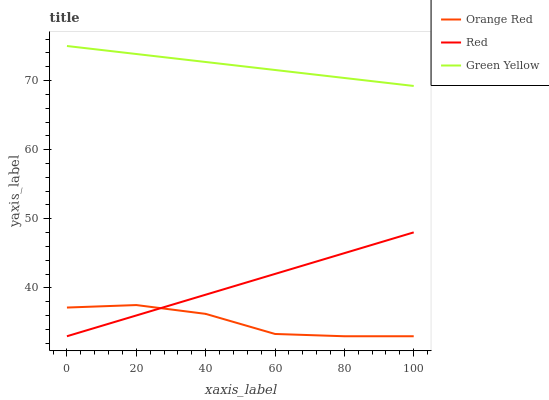Does Red have the minimum area under the curve?
Answer yes or no. No. Does Red have the maximum area under the curve?
Answer yes or no. No. Is Orange Red the smoothest?
Answer yes or no. No. Is Red the roughest?
Answer yes or no. No. Does Red have the highest value?
Answer yes or no. No. Is Red less than Green Yellow?
Answer yes or no. Yes. Is Green Yellow greater than Orange Red?
Answer yes or no. Yes. Does Red intersect Green Yellow?
Answer yes or no. No. 